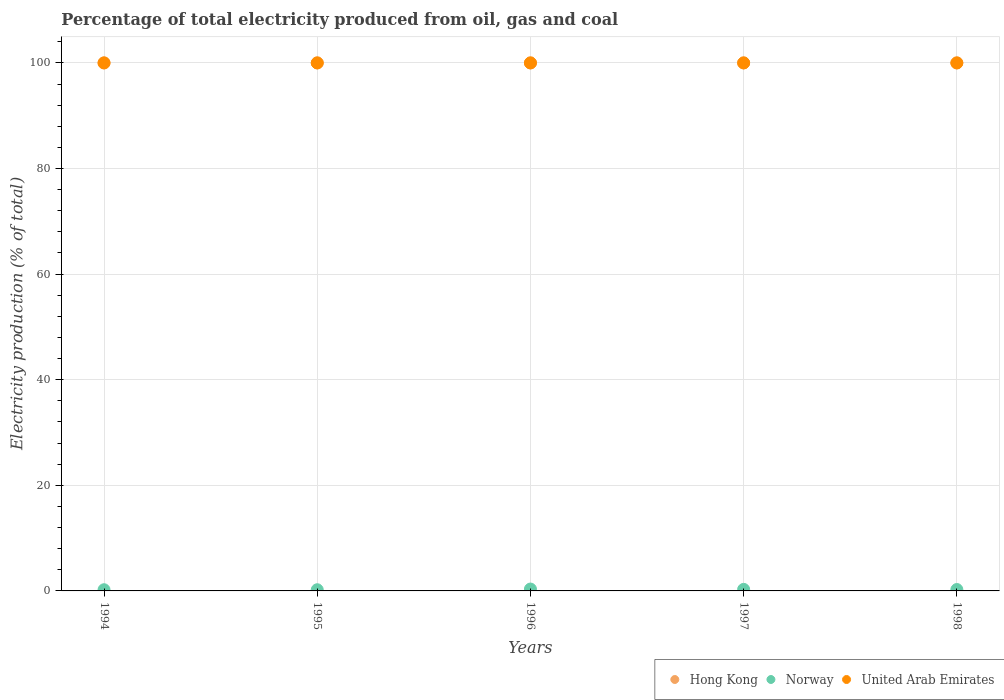Is the number of dotlines equal to the number of legend labels?
Your response must be concise. Yes. What is the electricity production in in United Arab Emirates in 1997?
Offer a terse response. 100. Across all years, what is the maximum electricity production in in Norway?
Make the answer very short. 0.35. In which year was the electricity production in in United Arab Emirates maximum?
Your answer should be very brief. 1994. In which year was the electricity production in in Hong Kong minimum?
Your answer should be compact. 1994. What is the total electricity production in in Norway in the graph?
Ensure brevity in your answer.  1.36. What is the difference between the electricity production in in Hong Kong in 1998 and the electricity production in in Norway in 1997?
Offer a terse response. 99.71. In the year 1998, what is the difference between the electricity production in in Norway and electricity production in in Hong Kong?
Make the answer very short. -99.74. What is the difference between the highest and the second highest electricity production in in United Arab Emirates?
Your answer should be compact. 0. What is the difference between the highest and the lowest electricity production in in United Arab Emirates?
Your answer should be compact. 0. Is the sum of the electricity production in in Hong Kong in 1996 and 1997 greater than the maximum electricity production in in United Arab Emirates across all years?
Keep it short and to the point. Yes. Is the electricity production in in United Arab Emirates strictly greater than the electricity production in in Norway over the years?
Keep it short and to the point. Yes. How are the legend labels stacked?
Keep it short and to the point. Horizontal. What is the title of the graph?
Your answer should be very brief. Percentage of total electricity produced from oil, gas and coal. Does "Yemen, Rep." appear as one of the legend labels in the graph?
Your answer should be very brief. No. What is the label or title of the X-axis?
Your answer should be very brief. Years. What is the label or title of the Y-axis?
Give a very brief answer. Electricity production (% of total). What is the Electricity production (% of total) of Hong Kong in 1994?
Provide a short and direct response. 100. What is the Electricity production (% of total) of Norway in 1994?
Give a very brief answer. 0.23. What is the Electricity production (% of total) of United Arab Emirates in 1994?
Ensure brevity in your answer.  100. What is the Electricity production (% of total) of Norway in 1995?
Offer a terse response. 0.22. What is the Electricity production (% of total) in Hong Kong in 1996?
Your answer should be very brief. 100. What is the Electricity production (% of total) in Norway in 1996?
Your answer should be very brief. 0.35. What is the Electricity production (% of total) of Norway in 1997?
Provide a short and direct response. 0.29. What is the Electricity production (% of total) of United Arab Emirates in 1997?
Your answer should be compact. 100. What is the Electricity production (% of total) of Norway in 1998?
Offer a terse response. 0.26. Across all years, what is the maximum Electricity production (% of total) in Hong Kong?
Your answer should be compact. 100. Across all years, what is the maximum Electricity production (% of total) of Norway?
Give a very brief answer. 0.35. Across all years, what is the maximum Electricity production (% of total) of United Arab Emirates?
Offer a terse response. 100. Across all years, what is the minimum Electricity production (% of total) in Norway?
Provide a succinct answer. 0.22. What is the total Electricity production (% of total) of Norway in the graph?
Offer a very short reply. 1.36. What is the total Electricity production (% of total) in United Arab Emirates in the graph?
Offer a terse response. 500. What is the difference between the Electricity production (% of total) in Norway in 1994 and that in 1995?
Offer a terse response. 0. What is the difference between the Electricity production (% of total) of Norway in 1994 and that in 1996?
Give a very brief answer. -0.13. What is the difference between the Electricity production (% of total) in Norway in 1994 and that in 1997?
Make the answer very short. -0.07. What is the difference between the Electricity production (% of total) in Hong Kong in 1994 and that in 1998?
Offer a terse response. 0. What is the difference between the Electricity production (% of total) in Norway in 1994 and that in 1998?
Your answer should be compact. -0.04. What is the difference between the Electricity production (% of total) in United Arab Emirates in 1994 and that in 1998?
Provide a succinct answer. 0. What is the difference between the Electricity production (% of total) of Hong Kong in 1995 and that in 1996?
Your answer should be very brief. 0. What is the difference between the Electricity production (% of total) in Norway in 1995 and that in 1996?
Keep it short and to the point. -0.13. What is the difference between the Electricity production (% of total) of Norway in 1995 and that in 1997?
Provide a short and direct response. -0.07. What is the difference between the Electricity production (% of total) of United Arab Emirates in 1995 and that in 1997?
Give a very brief answer. 0. What is the difference between the Electricity production (% of total) of Norway in 1995 and that in 1998?
Offer a very short reply. -0.04. What is the difference between the Electricity production (% of total) in Norway in 1996 and that in 1997?
Keep it short and to the point. 0.06. What is the difference between the Electricity production (% of total) in Hong Kong in 1996 and that in 1998?
Give a very brief answer. 0. What is the difference between the Electricity production (% of total) of Norway in 1996 and that in 1998?
Offer a very short reply. 0.09. What is the difference between the Electricity production (% of total) of United Arab Emirates in 1996 and that in 1998?
Provide a succinct answer. 0. What is the difference between the Electricity production (% of total) of Hong Kong in 1997 and that in 1998?
Ensure brevity in your answer.  0. What is the difference between the Electricity production (% of total) of Norway in 1997 and that in 1998?
Provide a short and direct response. 0.03. What is the difference between the Electricity production (% of total) in United Arab Emirates in 1997 and that in 1998?
Offer a terse response. 0. What is the difference between the Electricity production (% of total) of Hong Kong in 1994 and the Electricity production (% of total) of Norway in 1995?
Offer a very short reply. 99.78. What is the difference between the Electricity production (% of total) in Hong Kong in 1994 and the Electricity production (% of total) in United Arab Emirates in 1995?
Give a very brief answer. 0. What is the difference between the Electricity production (% of total) in Norway in 1994 and the Electricity production (% of total) in United Arab Emirates in 1995?
Your response must be concise. -99.77. What is the difference between the Electricity production (% of total) of Hong Kong in 1994 and the Electricity production (% of total) of Norway in 1996?
Offer a very short reply. 99.65. What is the difference between the Electricity production (% of total) in Norway in 1994 and the Electricity production (% of total) in United Arab Emirates in 1996?
Your answer should be very brief. -99.77. What is the difference between the Electricity production (% of total) of Hong Kong in 1994 and the Electricity production (% of total) of Norway in 1997?
Provide a succinct answer. 99.71. What is the difference between the Electricity production (% of total) of Hong Kong in 1994 and the Electricity production (% of total) of United Arab Emirates in 1997?
Your answer should be very brief. 0. What is the difference between the Electricity production (% of total) of Norway in 1994 and the Electricity production (% of total) of United Arab Emirates in 1997?
Keep it short and to the point. -99.77. What is the difference between the Electricity production (% of total) of Hong Kong in 1994 and the Electricity production (% of total) of Norway in 1998?
Make the answer very short. 99.74. What is the difference between the Electricity production (% of total) of Hong Kong in 1994 and the Electricity production (% of total) of United Arab Emirates in 1998?
Keep it short and to the point. 0. What is the difference between the Electricity production (% of total) of Norway in 1994 and the Electricity production (% of total) of United Arab Emirates in 1998?
Your answer should be compact. -99.77. What is the difference between the Electricity production (% of total) in Hong Kong in 1995 and the Electricity production (% of total) in Norway in 1996?
Ensure brevity in your answer.  99.65. What is the difference between the Electricity production (% of total) of Hong Kong in 1995 and the Electricity production (% of total) of United Arab Emirates in 1996?
Offer a terse response. 0. What is the difference between the Electricity production (% of total) of Norway in 1995 and the Electricity production (% of total) of United Arab Emirates in 1996?
Your answer should be very brief. -99.78. What is the difference between the Electricity production (% of total) of Hong Kong in 1995 and the Electricity production (% of total) of Norway in 1997?
Make the answer very short. 99.71. What is the difference between the Electricity production (% of total) in Hong Kong in 1995 and the Electricity production (% of total) in United Arab Emirates in 1997?
Your answer should be compact. 0. What is the difference between the Electricity production (% of total) in Norway in 1995 and the Electricity production (% of total) in United Arab Emirates in 1997?
Ensure brevity in your answer.  -99.78. What is the difference between the Electricity production (% of total) of Hong Kong in 1995 and the Electricity production (% of total) of Norway in 1998?
Your response must be concise. 99.74. What is the difference between the Electricity production (% of total) of Norway in 1995 and the Electricity production (% of total) of United Arab Emirates in 1998?
Make the answer very short. -99.78. What is the difference between the Electricity production (% of total) of Hong Kong in 1996 and the Electricity production (% of total) of Norway in 1997?
Make the answer very short. 99.71. What is the difference between the Electricity production (% of total) of Hong Kong in 1996 and the Electricity production (% of total) of United Arab Emirates in 1997?
Ensure brevity in your answer.  0. What is the difference between the Electricity production (% of total) of Norway in 1996 and the Electricity production (% of total) of United Arab Emirates in 1997?
Keep it short and to the point. -99.65. What is the difference between the Electricity production (% of total) of Hong Kong in 1996 and the Electricity production (% of total) of Norway in 1998?
Offer a terse response. 99.74. What is the difference between the Electricity production (% of total) in Norway in 1996 and the Electricity production (% of total) in United Arab Emirates in 1998?
Your answer should be compact. -99.65. What is the difference between the Electricity production (% of total) of Hong Kong in 1997 and the Electricity production (% of total) of Norway in 1998?
Your answer should be compact. 99.74. What is the difference between the Electricity production (% of total) of Hong Kong in 1997 and the Electricity production (% of total) of United Arab Emirates in 1998?
Your answer should be very brief. 0. What is the difference between the Electricity production (% of total) of Norway in 1997 and the Electricity production (% of total) of United Arab Emirates in 1998?
Keep it short and to the point. -99.71. What is the average Electricity production (% of total) in Norway per year?
Provide a succinct answer. 0.27. What is the average Electricity production (% of total) of United Arab Emirates per year?
Give a very brief answer. 100. In the year 1994, what is the difference between the Electricity production (% of total) of Hong Kong and Electricity production (% of total) of Norway?
Offer a very short reply. 99.77. In the year 1994, what is the difference between the Electricity production (% of total) in Hong Kong and Electricity production (% of total) in United Arab Emirates?
Provide a short and direct response. 0. In the year 1994, what is the difference between the Electricity production (% of total) in Norway and Electricity production (% of total) in United Arab Emirates?
Provide a succinct answer. -99.77. In the year 1995, what is the difference between the Electricity production (% of total) of Hong Kong and Electricity production (% of total) of Norway?
Your answer should be compact. 99.78. In the year 1995, what is the difference between the Electricity production (% of total) of Hong Kong and Electricity production (% of total) of United Arab Emirates?
Keep it short and to the point. 0. In the year 1995, what is the difference between the Electricity production (% of total) in Norway and Electricity production (% of total) in United Arab Emirates?
Your answer should be compact. -99.78. In the year 1996, what is the difference between the Electricity production (% of total) of Hong Kong and Electricity production (% of total) of Norway?
Your response must be concise. 99.65. In the year 1996, what is the difference between the Electricity production (% of total) in Hong Kong and Electricity production (% of total) in United Arab Emirates?
Give a very brief answer. 0. In the year 1996, what is the difference between the Electricity production (% of total) of Norway and Electricity production (% of total) of United Arab Emirates?
Your answer should be very brief. -99.65. In the year 1997, what is the difference between the Electricity production (% of total) in Hong Kong and Electricity production (% of total) in Norway?
Provide a short and direct response. 99.71. In the year 1997, what is the difference between the Electricity production (% of total) of Hong Kong and Electricity production (% of total) of United Arab Emirates?
Your answer should be very brief. 0. In the year 1997, what is the difference between the Electricity production (% of total) in Norway and Electricity production (% of total) in United Arab Emirates?
Make the answer very short. -99.71. In the year 1998, what is the difference between the Electricity production (% of total) of Hong Kong and Electricity production (% of total) of Norway?
Your answer should be very brief. 99.74. In the year 1998, what is the difference between the Electricity production (% of total) of Hong Kong and Electricity production (% of total) of United Arab Emirates?
Provide a succinct answer. 0. In the year 1998, what is the difference between the Electricity production (% of total) of Norway and Electricity production (% of total) of United Arab Emirates?
Keep it short and to the point. -99.74. What is the ratio of the Electricity production (% of total) of Norway in 1994 to that in 1995?
Provide a short and direct response. 1.01. What is the ratio of the Electricity production (% of total) in United Arab Emirates in 1994 to that in 1995?
Keep it short and to the point. 1. What is the ratio of the Electricity production (% of total) of Norway in 1994 to that in 1996?
Make the answer very short. 0.64. What is the ratio of the Electricity production (% of total) in United Arab Emirates in 1994 to that in 1996?
Ensure brevity in your answer.  1. What is the ratio of the Electricity production (% of total) in Hong Kong in 1994 to that in 1997?
Give a very brief answer. 1. What is the ratio of the Electricity production (% of total) of Norway in 1994 to that in 1997?
Ensure brevity in your answer.  0.77. What is the ratio of the Electricity production (% of total) in Norway in 1994 to that in 1998?
Offer a terse response. 0.85. What is the ratio of the Electricity production (% of total) in Hong Kong in 1995 to that in 1996?
Provide a succinct answer. 1. What is the ratio of the Electricity production (% of total) in Norway in 1995 to that in 1996?
Give a very brief answer. 0.63. What is the ratio of the Electricity production (% of total) of United Arab Emirates in 1995 to that in 1996?
Ensure brevity in your answer.  1. What is the ratio of the Electricity production (% of total) of Hong Kong in 1995 to that in 1997?
Your answer should be very brief. 1. What is the ratio of the Electricity production (% of total) of Norway in 1995 to that in 1997?
Ensure brevity in your answer.  0.76. What is the ratio of the Electricity production (% of total) in United Arab Emirates in 1995 to that in 1997?
Offer a very short reply. 1. What is the ratio of the Electricity production (% of total) in Norway in 1995 to that in 1998?
Ensure brevity in your answer.  0.84. What is the ratio of the Electricity production (% of total) in United Arab Emirates in 1995 to that in 1998?
Keep it short and to the point. 1. What is the ratio of the Electricity production (% of total) of Hong Kong in 1996 to that in 1997?
Keep it short and to the point. 1. What is the ratio of the Electricity production (% of total) in Norway in 1996 to that in 1997?
Offer a terse response. 1.21. What is the ratio of the Electricity production (% of total) of United Arab Emirates in 1996 to that in 1997?
Offer a terse response. 1. What is the ratio of the Electricity production (% of total) in Norway in 1996 to that in 1998?
Offer a terse response. 1.34. What is the ratio of the Electricity production (% of total) of Norway in 1997 to that in 1998?
Provide a succinct answer. 1.11. What is the difference between the highest and the second highest Electricity production (% of total) in Norway?
Offer a very short reply. 0.06. What is the difference between the highest and the second highest Electricity production (% of total) of United Arab Emirates?
Make the answer very short. 0. What is the difference between the highest and the lowest Electricity production (% of total) in Norway?
Keep it short and to the point. 0.13. 